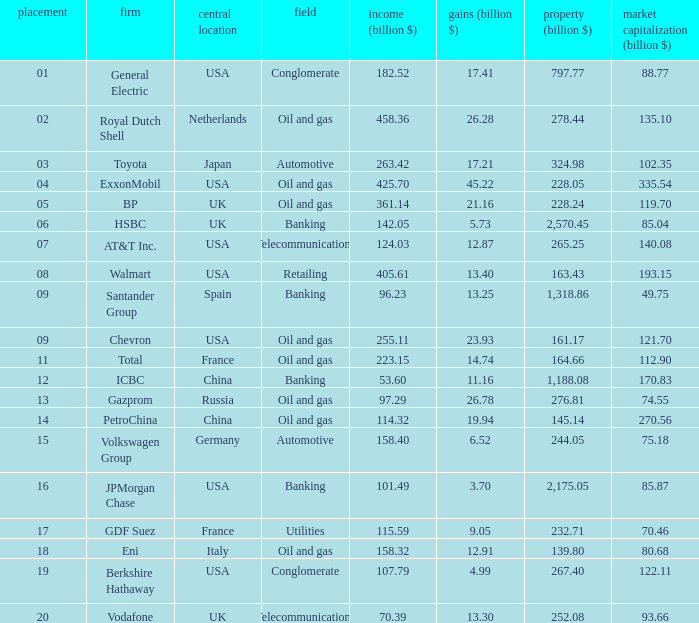How many Assets (billion $) has an Industry of oil and gas, and a Rank of 9, and a Market Value (billion $) larger than 121.7? None. 